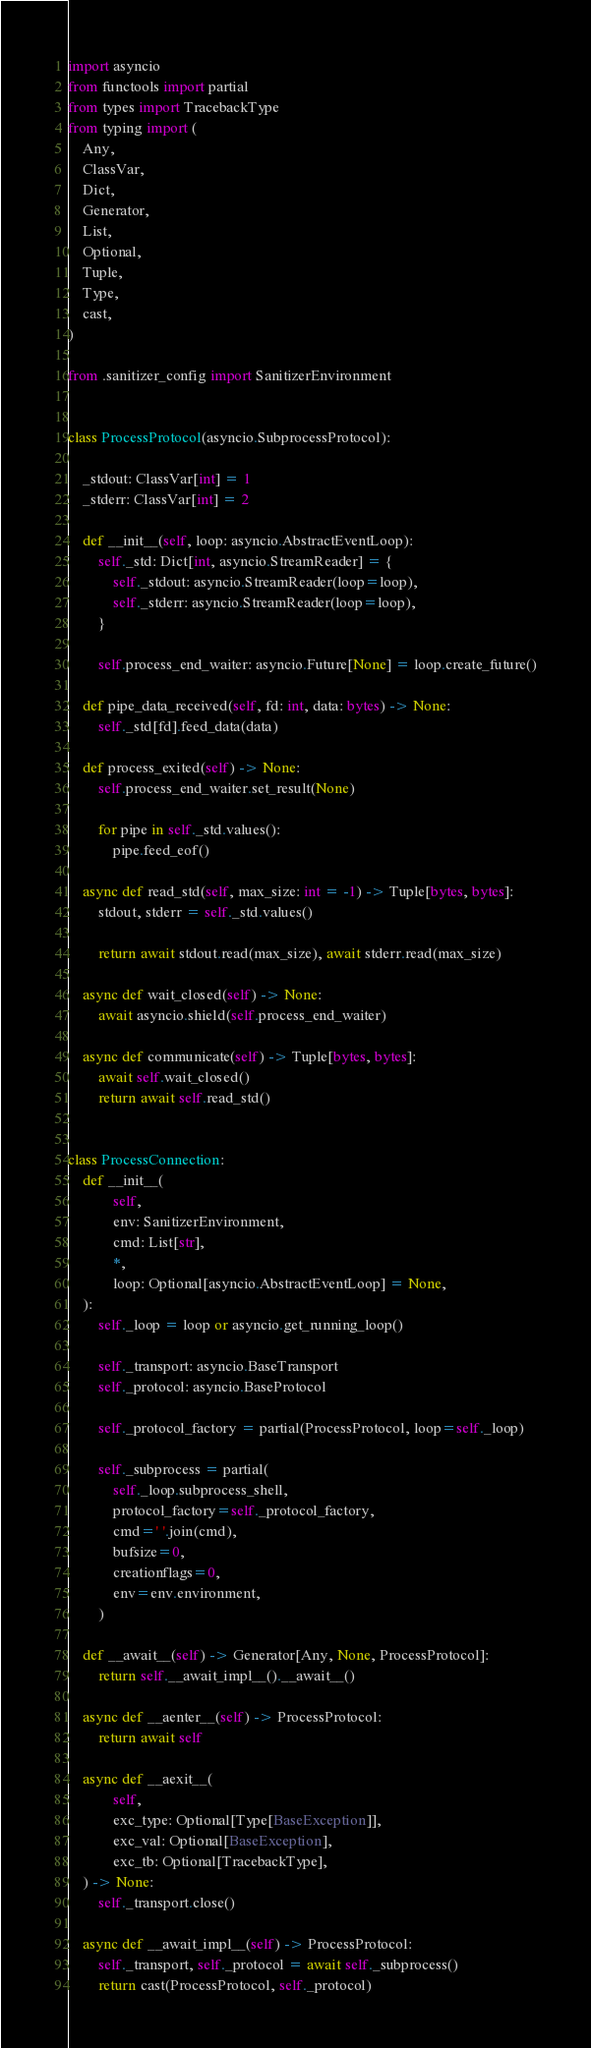Convert code to text. <code><loc_0><loc_0><loc_500><loc_500><_Python_>import asyncio
from functools import partial
from types import TracebackType
from typing import (
    Any,
    ClassVar,
    Dict,
    Generator,
    List,
    Optional,
    Tuple,
    Type,
    cast,
)

from .sanitizer_config import SanitizerEnvironment


class ProcessProtocol(asyncio.SubprocessProtocol):

    _stdout: ClassVar[int] = 1
    _stderr: ClassVar[int] = 2

    def __init__(self, loop: asyncio.AbstractEventLoop):
        self._std: Dict[int, asyncio.StreamReader] = {
            self._stdout: asyncio.StreamReader(loop=loop),
            self._stderr: asyncio.StreamReader(loop=loop),
        }

        self.process_end_waiter: asyncio.Future[None] = loop.create_future()

    def pipe_data_received(self, fd: int, data: bytes) -> None:
        self._std[fd].feed_data(data)

    def process_exited(self) -> None:
        self.process_end_waiter.set_result(None)

        for pipe in self._std.values():
            pipe.feed_eof()

    async def read_std(self, max_size: int = -1) -> Tuple[bytes, bytes]:
        stdout, stderr = self._std.values()

        return await stdout.read(max_size), await stderr.read(max_size)

    async def wait_closed(self) -> None:
        await asyncio.shield(self.process_end_waiter)

    async def communicate(self) -> Tuple[bytes, bytes]:
        await self.wait_closed()
        return await self.read_std()


class ProcessConnection:
    def __init__(
            self,
            env: SanitizerEnvironment,
            cmd: List[str],
            *,
            loop: Optional[asyncio.AbstractEventLoop] = None,
    ):
        self._loop = loop or asyncio.get_running_loop()

        self._transport: asyncio.BaseTransport
        self._protocol: asyncio.BaseProtocol

        self._protocol_factory = partial(ProcessProtocol, loop=self._loop)

        self._subprocess = partial(
            self._loop.subprocess_shell,
            protocol_factory=self._protocol_factory,
            cmd=' '.join(cmd),
            bufsize=0,
            creationflags=0,
            env=env.environment,
        )

    def __await__(self) -> Generator[Any, None, ProcessProtocol]:
        return self.__await_impl__().__await__()

    async def __aenter__(self) -> ProcessProtocol:
        return await self

    async def __aexit__(
            self,
            exc_type: Optional[Type[BaseException]],
            exc_val: Optional[BaseException],
            exc_tb: Optional[TracebackType],
    ) -> None:
        self._transport.close()

    async def __await_impl__(self) -> ProcessProtocol:
        self._transport, self._protocol = await self._subprocess()
        return cast(ProcessProtocol, self._protocol)
</code> 